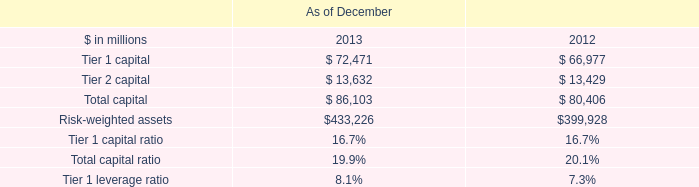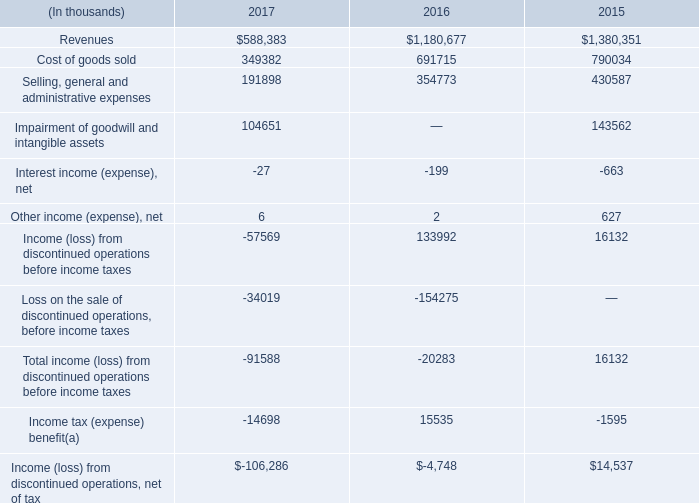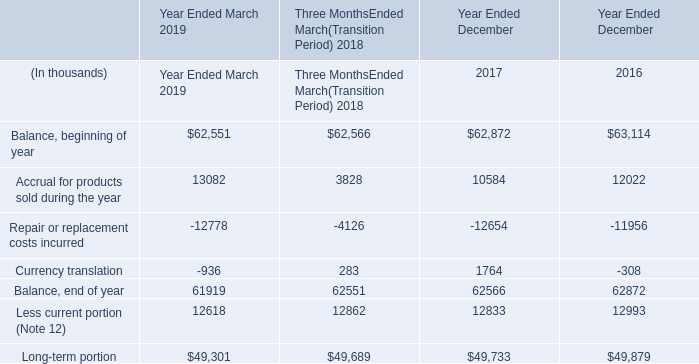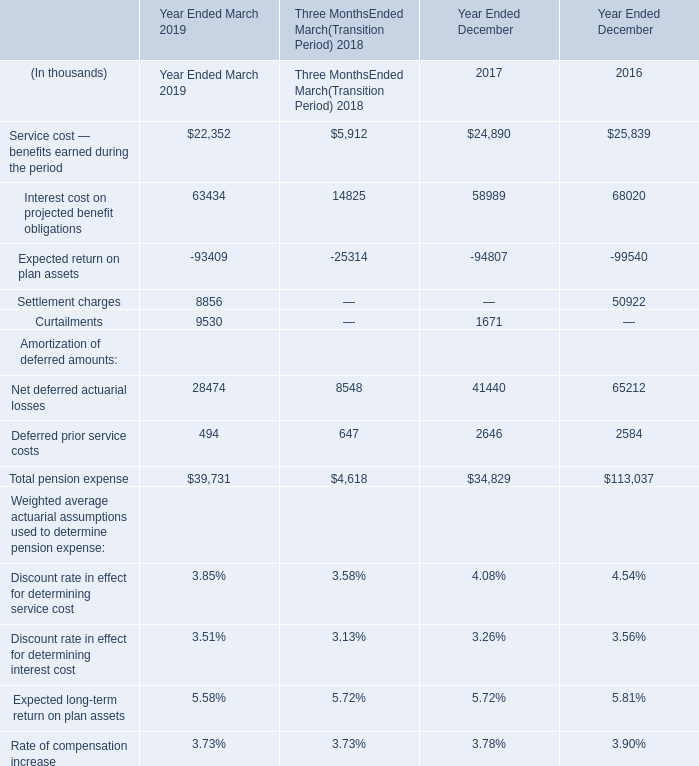What is the ratio of Curtailments to the total in Year Ended December 2017? 
Computations: (1671 / 34829)
Answer: 0.04798. 